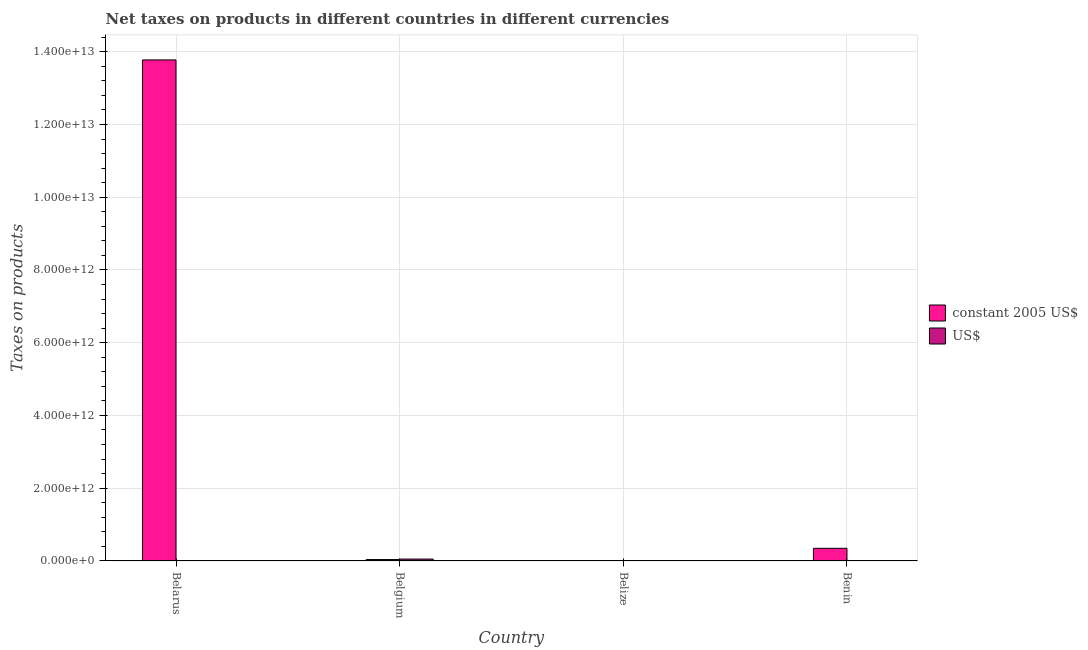How many different coloured bars are there?
Provide a short and direct response. 2. How many bars are there on the 3rd tick from the left?
Your answer should be very brief. 2. How many bars are there on the 3rd tick from the right?
Make the answer very short. 2. What is the label of the 4th group of bars from the left?
Provide a succinct answer. Benin. In how many cases, is the number of bars for a given country not equal to the number of legend labels?
Your response must be concise. 0. What is the net taxes in us$ in Belize?
Offer a terse response. 1.79e+08. Across all countries, what is the maximum net taxes in constant 2005 us$?
Make the answer very short. 1.38e+13. Across all countries, what is the minimum net taxes in us$?
Offer a terse response. 1.79e+08. In which country was the net taxes in us$ maximum?
Keep it short and to the point. Belgium. In which country was the net taxes in us$ minimum?
Provide a succinct answer. Belize. What is the total net taxes in us$ in the graph?
Give a very brief answer. 5.76e+1. What is the difference between the net taxes in us$ in Belarus and that in Belize?
Your response must be concise. 6.24e+09. What is the difference between the net taxes in us$ in Benin and the net taxes in constant 2005 us$ in Belgium?
Make the answer very short. -3.60e+1. What is the average net taxes in us$ per country?
Your answer should be compact. 1.44e+1. What is the difference between the net taxes in us$ and net taxes in constant 2005 us$ in Belize?
Your answer should be compact. -1.79e+08. In how many countries, is the net taxes in us$ greater than 10800000000000 units?
Your answer should be compact. 0. What is the ratio of the net taxes in us$ in Belarus to that in Belize?
Provide a short and direct response. 35.78. Is the net taxes in constant 2005 us$ in Belgium less than that in Benin?
Your answer should be compact. Yes. Is the difference between the net taxes in constant 2005 us$ in Belarus and Belize greater than the difference between the net taxes in us$ in Belarus and Belize?
Your response must be concise. Yes. What is the difference between the highest and the second highest net taxes in constant 2005 us$?
Give a very brief answer. 1.34e+13. What is the difference between the highest and the lowest net taxes in us$?
Offer a terse response. 5.01e+1. What does the 2nd bar from the left in Belize represents?
Keep it short and to the point. US$. What does the 1st bar from the right in Benin represents?
Your answer should be compact. US$. What is the difference between two consecutive major ticks on the Y-axis?
Provide a succinct answer. 2.00e+12. Does the graph contain grids?
Your answer should be very brief. Yes. Where does the legend appear in the graph?
Your answer should be very brief. Center right. How many legend labels are there?
Your answer should be very brief. 2. What is the title of the graph?
Offer a very short reply. Net taxes on products in different countries in different currencies. Does "Register a property" appear as one of the legend labels in the graph?
Provide a succinct answer. No. What is the label or title of the X-axis?
Offer a very short reply. Country. What is the label or title of the Y-axis?
Offer a very short reply. Taxes on products. What is the Taxes on products in constant 2005 US$ in Belarus?
Provide a short and direct response. 1.38e+13. What is the Taxes on products of US$ in Belarus?
Offer a very short reply. 6.42e+09. What is the Taxes on products of constant 2005 US$ in Belgium?
Provide a succinct answer. 3.68e+1. What is the Taxes on products in US$ in Belgium?
Offer a very short reply. 5.03e+1. What is the Taxes on products in constant 2005 US$ in Belize?
Make the answer very short. 3.59e+08. What is the Taxes on products of US$ in Belize?
Your response must be concise. 1.79e+08. What is the Taxes on products in constant 2005 US$ in Benin?
Your response must be concise. 3.46e+11. What is the Taxes on products in US$ in Benin?
Make the answer very short. 7.22e+08. Across all countries, what is the maximum Taxes on products of constant 2005 US$?
Your response must be concise. 1.38e+13. Across all countries, what is the maximum Taxes on products of US$?
Make the answer very short. 5.03e+1. Across all countries, what is the minimum Taxes on products of constant 2005 US$?
Give a very brief answer. 3.59e+08. Across all countries, what is the minimum Taxes on products in US$?
Make the answer very short. 1.79e+08. What is the total Taxes on products of constant 2005 US$ in the graph?
Offer a terse response. 1.42e+13. What is the total Taxes on products of US$ in the graph?
Provide a short and direct response. 5.76e+1. What is the difference between the Taxes on products of constant 2005 US$ in Belarus and that in Belgium?
Keep it short and to the point. 1.37e+13. What is the difference between the Taxes on products of US$ in Belarus and that in Belgium?
Provide a short and direct response. -4.39e+1. What is the difference between the Taxes on products of constant 2005 US$ in Belarus and that in Belize?
Your response must be concise. 1.38e+13. What is the difference between the Taxes on products of US$ in Belarus and that in Belize?
Keep it short and to the point. 6.24e+09. What is the difference between the Taxes on products of constant 2005 US$ in Belarus and that in Benin?
Give a very brief answer. 1.34e+13. What is the difference between the Taxes on products of US$ in Belarus and that in Benin?
Provide a short and direct response. 5.70e+09. What is the difference between the Taxes on products in constant 2005 US$ in Belgium and that in Belize?
Your answer should be compact. 3.64e+1. What is the difference between the Taxes on products in US$ in Belgium and that in Belize?
Your response must be concise. 5.01e+1. What is the difference between the Taxes on products in constant 2005 US$ in Belgium and that in Benin?
Your answer should be compact. -3.09e+11. What is the difference between the Taxes on products in US$ in Belgium and that in Benin?
Offer a very short reply. 4.96e+1. What is the difference between the Taxes on products of constant 2005 US$ in Belize and that in Benin?
Provide a short and direct response. -3.46e+11. What is the difference between the Taxes on products of US$ in Belize and that in Benin?
Offer a terse response. -5.43e+08. What is the difference between the Taxes on products in constant 2005 US$ in Belarus and the Taxes on products in US$ in Belgium?
Give a very brief answer. 1.37e+13. What is the difference between the Taxes on products of constant 2005 US$ in Belarus and the Taxes on products of US$ in Belize?
Offer a terse response. 1.38e+13. What is the difference between the Taxes on products of constant 2005 US$ in Belarus and the Taxes on products of US$ in Benin?
Ensure brevity in your answer.  1.38e+13. What is the difference between the Taxes on products of constant 2005 US$ in Belgium and the Taxes on products of US$ in Belize?
Provide a short and direct response. 3.66e+1. What is the difference between the Taxes on products of constant 2005 US$ in Belgium and the Taxes on products of US$ in Benin?
Keep it short and to the point. 3.60e+1. What is the difference between the Taxes on products of constant 2005 US$ in Belize and the Taxes on products of US$ in Benin?
Give a very brief answer. -3.63e+08. What is the average Taxes on products of constant 2005 US$ per country?
Make the answer very short. 3.54e+12. What is the average Taxes on products in US$ per country?
Offer a terse response. 1.44e+1. What is the difference between the Taxes on products in constant 2005 US$ and Taxes on products in US$ in Belarus?
Your answer should be compact. 1.38e+13. What is the difference between the Taxes on products of constant 2005 US$ and Taxes on products of US$ in Belgium?
Your answer should be compact. -1.36e+1. What is the difference between the Taxes on products in constant 2005 US$ and Taxes on products in US$ in Belize?
Provide a short and direct response. 1.79e+08. What is the difference between the Taxes on products of constant 2005 US$ and Taxes on products of US$ in Benin?
Offer a very short reply. 3.45e+11. What is the ratio of the Taxes on products of constant 2005 US$ in Belarus to that in Belgium?
Provide a short and direct response. 374.83. What is the ratio of the Taxes on products of US$ in Belarus to that in Belgium?
Your response must be concise. 0.13. What is the ratio of the Taxes on products of constant 2005 US$ in Belarus to that in Belize?
Make the answer very short. 3.84e+04. What is the ratio of the Taxes on products of US$ in Belarus to that in Belize?
Make the answer very short. 35.78. What is the ratio of the Taxes on products of constant 2005 US$ in Belarus to that in Benin?
Your answer should be very brief. 39.8. What is the ratio of the Taxes on products of US$ in Belarus to that in Benin?
Offer a very short reply. 8.89. What is the ratio of the Taxes on products in constant 2005 US$ in Belgium to that in Belize?
Your answer should be compact. 102.44. What is the ratio of the Taxes on products in US$ in Belgium to that in Belize?
Give a very brief answer. 280.42. What is the ratio of the Taxes on products in constant 2005 US$ in Belgium to that in Benin?
Provide a succinct answer. 0.11. What is the ratio of the Taxes on products in US$ in Belgium to that in Benin?
Make the answer very short. 69.66. What is the ratio of the Taxes on products of US$ in Belize to that in Benin?
Your answer should be very brief. 0.25. What is the difference between the highest and the second highest Taxes on products of constant 2005 US$?
Your answer should be very brief. 1.34e+13. What is the difference between the highest and the second highest Taxes on products in US$?
Ensure brevity in your answer.  4.39e+1. What is the difference between the highest and the lowest Taxes on products in constant 2005 US$?
Keep it short and to the point. 1.38e+13. What is the difference between the highest and the lowest Taxes on products in US$?
Make the answer very short. 5.01e+1. 